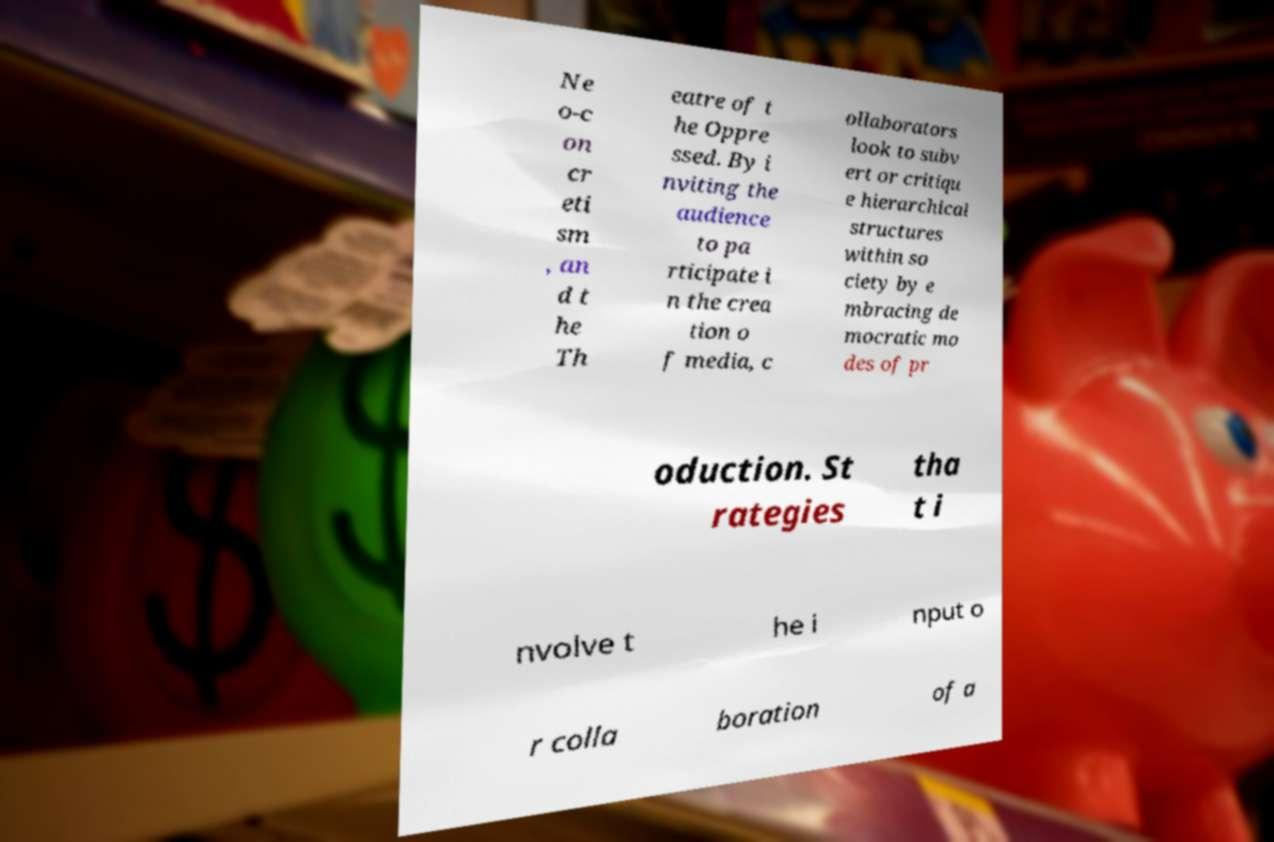For documentation purposes, I need the text within this image transcribed. Could you provide that? Ne o-c on cr eti sm , an d t he Th eatre of t he Oppre ssed. By i nviting the audience to pa rticipate i n the crea tion o f media, c ollaborators look to subv ert or critiqu e hierarchical structures within so ciety by e mbracing de mocratic mo des of pr oduction. St rategies tha t i nvolve t he i nput o r colla boration of a 